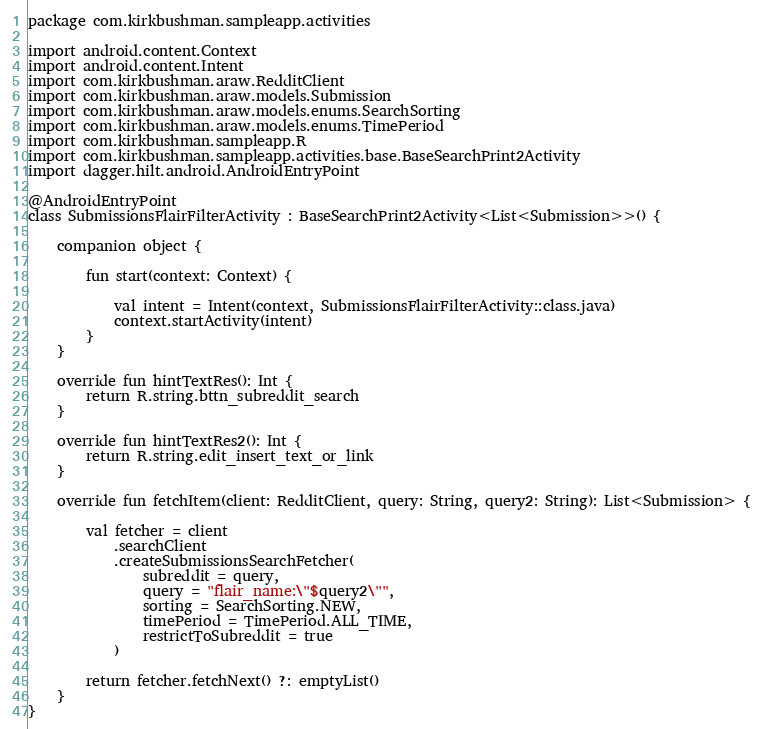<code> <loc_0><loc_0><loc_500><loc_500><_Kotlin_>package com.kirkbushman.sampleapp.activities

import android.content.Context
import android.content.Intent
import com.kirkbushman.araw.RedditClient
import com.kirkbushman.araw.models.Submission
import com.kirkbushman.araw.models.enums.SearchSorting
import com.kirkbushman.araw.models.enums.TimePeriod
import com.kirkbushman.sampleapp.R
import com.kirkbushman.sampleapp.activities.base.BaseSearchPrint2Activity
import dagger.hilt.android.AndroidEntryPoint

@AndroidEntryPoint
class SubmissionsFlairFilterActivity : BaseSearchPrint2Activity<List<Submission>>() {

    companion object {

        fun start(context: Context) {

            val intent = Intent(context, SubmissionsFlairFilterActivity::class.java)
            context.startActivity(intent)
        }
    }

    override fun hintTextRes(): Int {
        return R.string.bttn_subreddit_search
    }

    override fun hintTextRes2(): Int {
        return R.string.edit_insert_text_or_link
    }

    override fun fetchItem(client: RedditClient, query: String, query2: String): List<Submission> {

        val fetcher = client
            .searchClient
            .createSubmissionsSearchFetcher(
                subreddit = query,
                query = "flair_name:\"$query2\"",
                sorting = SearchSorting.NEW,
                timePeriod = TimePeriod.ALL_TIME,
                restrictToSubreddit = true
            )

        return fetcher.fetchNext() ?: emptyList()
    }
}
</code> 